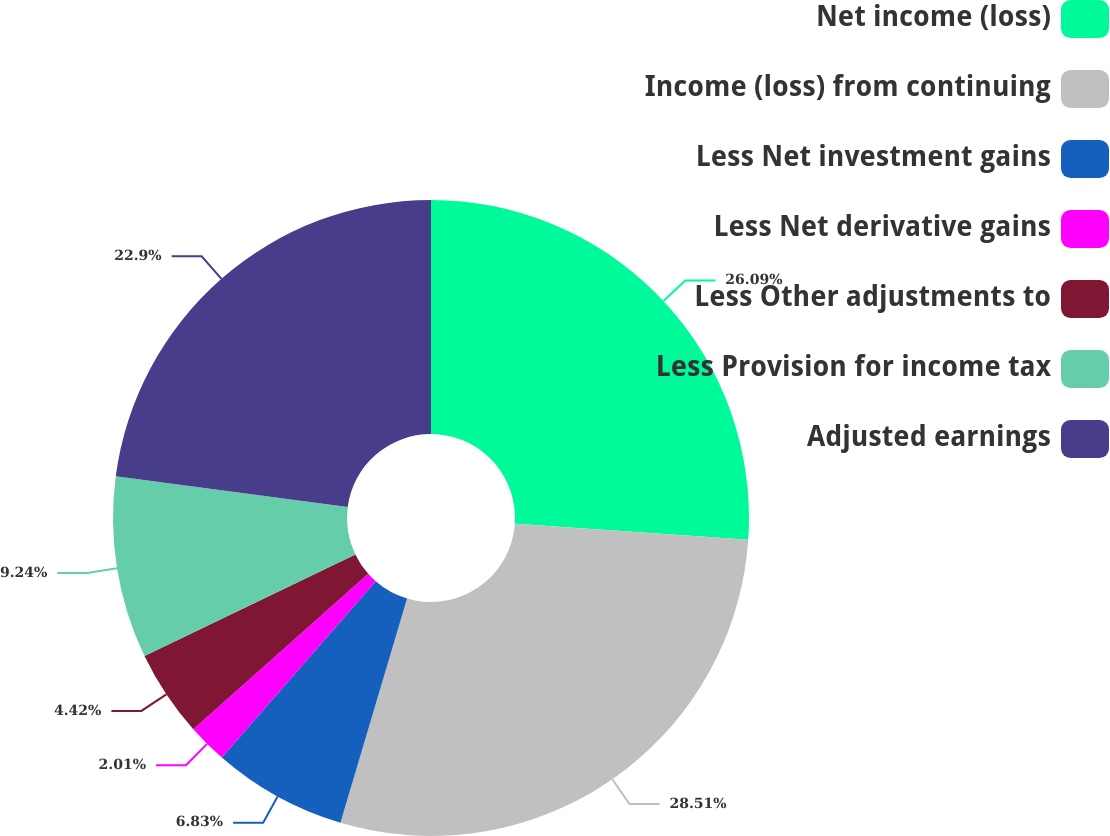<chart> <loc_0><loc_0><loc_500><loc_500><pie_chart><fcel>Net income (loss)<fcel>Income (loss) from continuing<fcel>Less Net investment gains<fcel>Less Net derivative gains<fcel>Less Other adjustments to<fcel>Less Provision for income tax<fcel>Adjusted earnings<nl><fcel>26.09%<fcel>28.5%<fcel>6.83%<fcel>2.01%<fcel>4.42%<fcel>9.24%<fcel>22.9%<nl></chart> 